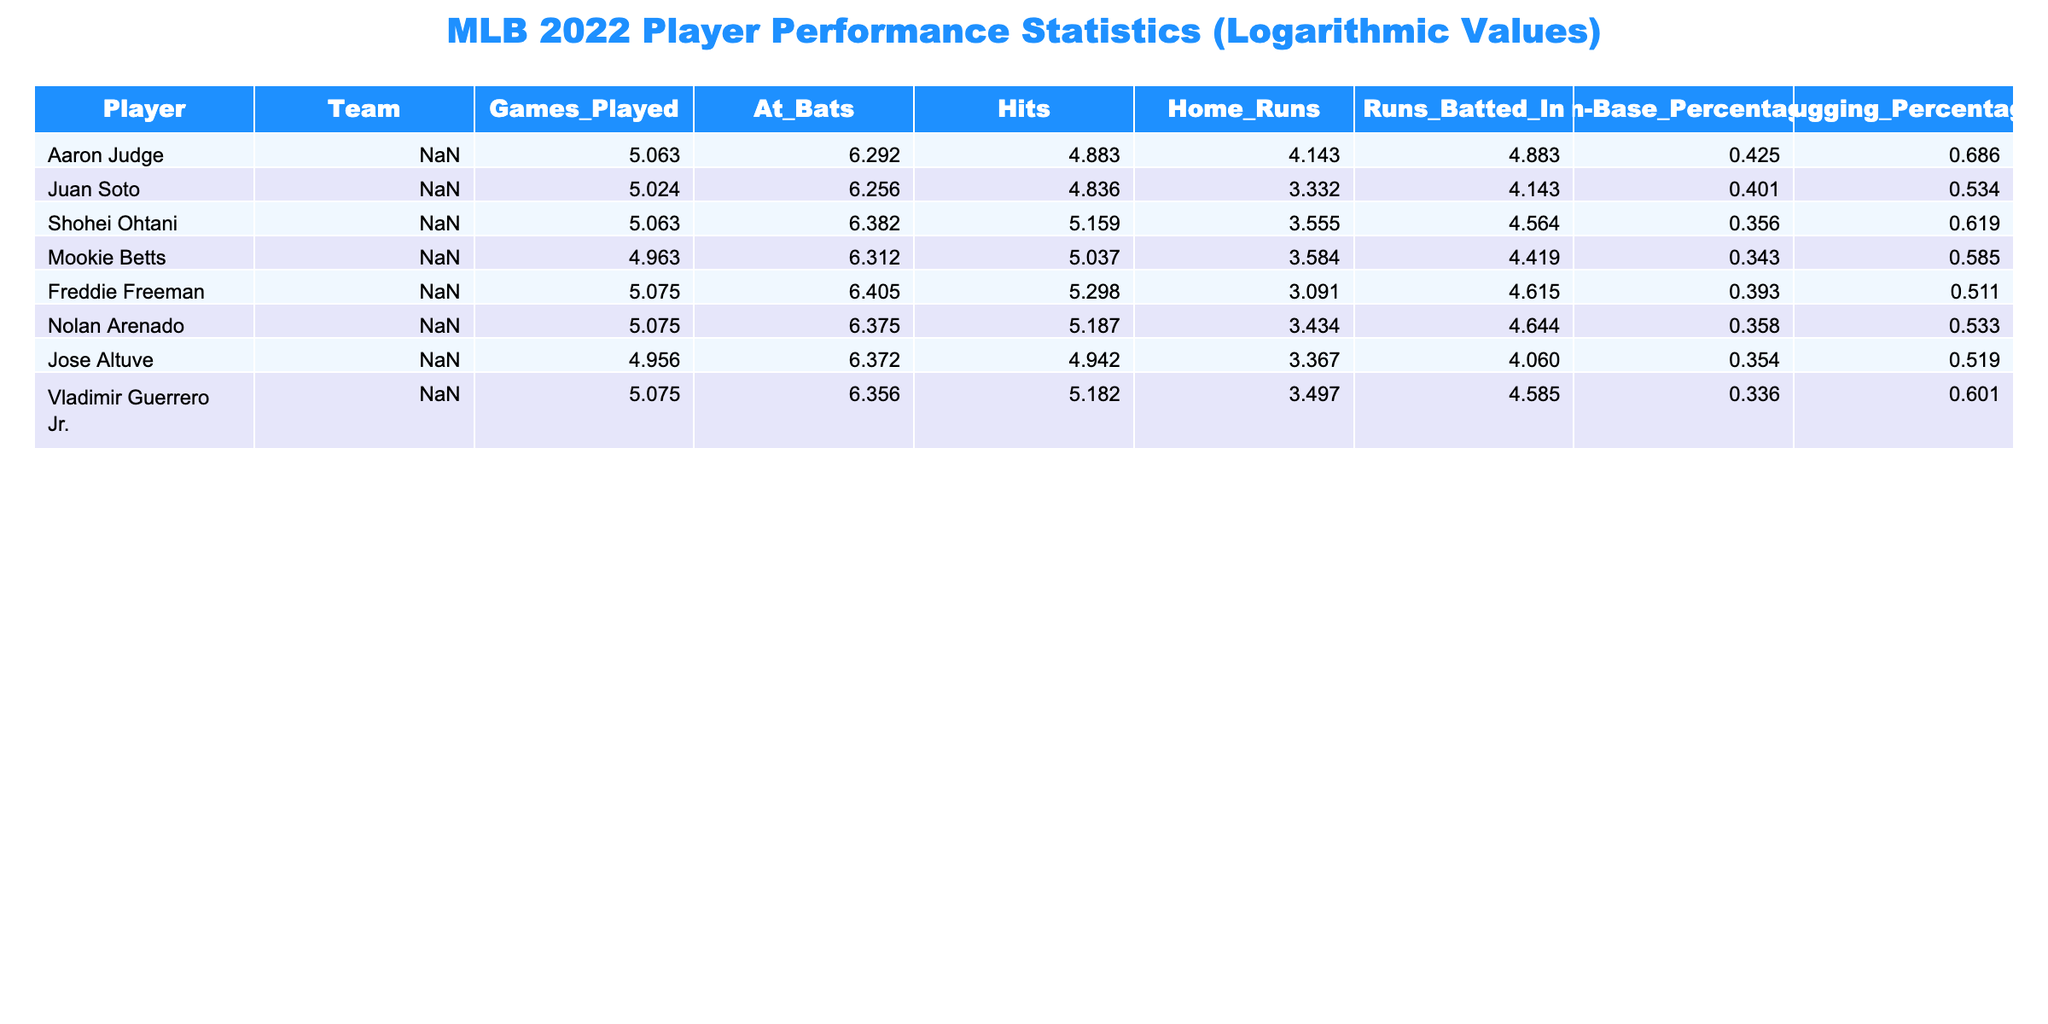What is the highest number of home runs hit by a player in the table? The home runs column shows that Aaron Judge hit 62 home runs, which is the highest value when compared to the other players listed.
Answer: 62 Which player has the highest on-base percentage? By examining the on-base percentage column, Aaron Judge has the highest on-base percentage of 0.425 among the players in the table.
Answer: 0.425 What is the total number of home runs hit by all players in the table? Adding the home runs of all players gives us (62 + 27 + 34 + 35 + 21 + 30 + 28 + 32) =  269.
Answer: 269 Is it true that Shohei Ohtani had more hits than Juan Soto? Comparing the hits columns, Shohei Ohtani had 173 hits while Juan Soto had 125 hits, making the statement true.
Answer: True How does Mookie Betts' slugging percentage compare with that of Freddie Freeman? Mookie Betts has a slugging percentage of 0.585 and Freddie Freeman has a slugging percentage of 0.511. Therefore, Mookie Betts has a higher slugging percentage.
Answer: Mookie Betts has a higher slugging percentage Which player had the most runs batted in, and what was the value? The runs batted in column shows that Aaron Judge had 131 runs batted in, which is the maximum value among the players in the table.
Answer: 131 What is the average number of games played by the players listed? To calculate the average, sum the games played (157 + 151 + 157 + 142 + 159 + 159 + 141 + 159) = 1225, then divide by 8 players: 1225 / 8 = 153.125. Thus, the average is approximately 153.13.
Answer: 153.13 Who had more hits, Vladimir Guerrero Jr. or Jose Altuve? Comparing the hits, Vladimir Guerrero Jr. had 177 hits while Jose Altuve had 139 hits, indicating Vladimir Guerrero Jr. had more hits.
Answer: Vladimir Guerrero Jr. had more hits Which team had the player with the highest number of runs batted in? Looking at the runs batted in column, Aaron Judge from the Yankees has the highest, with 131 runs batted in. Therefore, the Yankees had the player with the highest runs batted in.
Answer: Yankees 